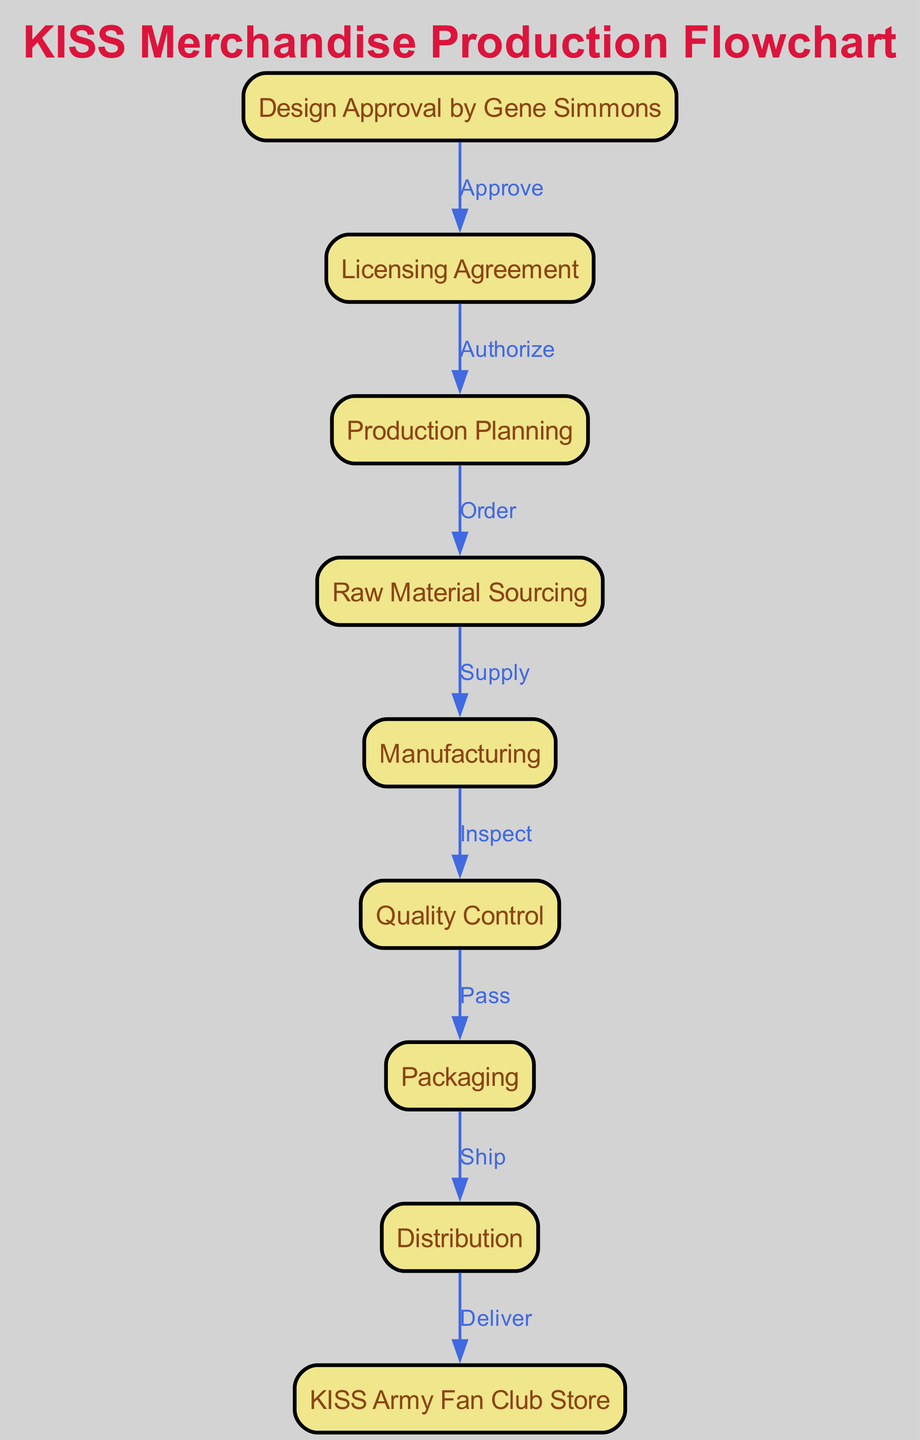What is the first step in the production line? The first step in the production line is the "Design Approval by Gene Simmons." This node is positioned at the top of the flow chart, indicating the initial action that must occur before any subsequent steps can take place.
Answer: Design Approval by Gene Simmons How many nodes are there in the diagram? The diagram contains nine nodes, each representing a specific stage in the KISS merchandise production flowchart. This can be counted directly from the list provided under "nodes" in the data.
Answer: Nine What is the label for the edge connecting "Licensing Agreement" to "Production Planning"? The label for the edge connecting "Licensing Agreement" to "Production Planning" is "Authorize." This connection indicates the action that must take place between these two nodes in the flowchart.
Answer: Authorize Which step comes after "Quality Control"? The step that comes after "Quality Control" is "Packaging." By following the directed edges in the flowchart, it is clear that the flow proceeds directly from "Quality Control" to "Packaging."
Answer: Packaging What is the final destination in the flowchart? The final destination in the flowchart is the "KISS Army Fan Club Store." This is the last node that receives merchandise in the production line, illustrating where the product ultimately ends up after all previous steps.
Answer: KISS Army Fan Club Store Describe the relationship between "Manufacturing" and "Quality Control." The relationship between "Manufacturing" and "Quality Control" is defined by the edge labeled "Inspect." This means that after manufacturing is complete, the produced items must undergo inspection before moving to the next stage.
Answer: Inspect How many edges are there in the diagram? The diagram has eight edges, which represent the various actions that take place between the nodes. This can be confirmed by counting the edges listed under "edges" in the data provided.
Answer: Eight What must happen before "Raw Material Sourcing"? Before "Raw Material Sourcing," "Production Planning" must occur. The diagram indicates that "Production Planning" directly leads to "Raw Material Sourcing" in a sequential manner.
Answer: Production Planning 